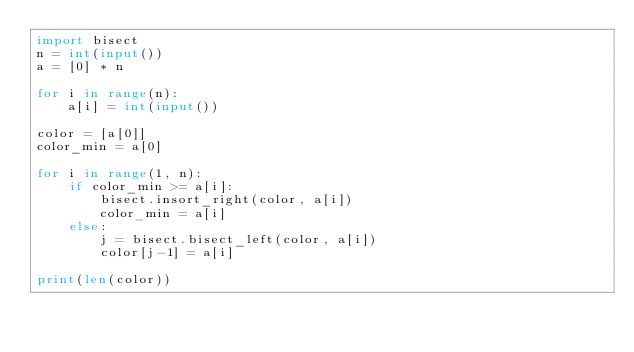<code> <loc_0><loc_0><loc_500><loc_500><_Python_>import bisect
n = int(input())
a = [0] * n

for i in range(n):
    a[i] = int(input())

color = [a[0]]
color_min = a[0]

for i in range(1, n):
    if color_min >= a[i]:
        bisect.insort_right(color, a[i])
        color_min = a[i]
    else:
        j = bisect.bisect_left(color, a[i])
        color[j-1] = a[i]

print(len(color))

        

</code> 